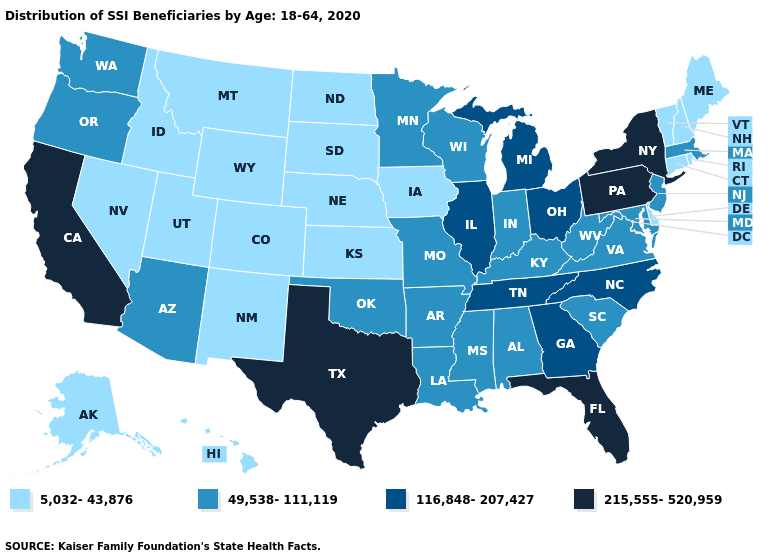Does Kentucky have the highest value in the South?
Give a very brief answer. No. Does the first symbol in the legend represent the smallest category?
Concise answer only. Yes. Which states have the highest value in the USA?
Write a very short answer. California, Florida, New York, Pennsylvania, Texas. Which states have the highest value in the USA?
Be succinct. California, Florida, New York, Pennsylvania, Texas. Name the states that have a value in the range 49,538-111,119?
Answer briefly. Alabama, Arizona, Arkansas, Indiana, Kentucky, Louisiana, Maryland, Massachusetts, Minnesota, Mississippi, Missouri, New Jersey, Oklahoma, Oregon, South Carolina, Virginia, Washington, West Virginia, Wisconsin. What is the lowest value in the USA?
Be succinct. 5,032-43,876. Name the states that have a value in the range 116,848-207,427?
Concise answer only. Georgia, Illinois, Michigan, North Carolina, Ohio, Tennessee. What is the value of Indiana?
Concise answer only. 49,538-111,119. Name the states that have a value in the range 215,555-520,959?
Answer briefly. California, Florida, New York, Pennsylvania, Texas. Name the states that have a value in the range 215,555-520,959?
Concise answer only. California, Florida, New York, Pennsylvania, Texas. Name the states that have a value in the range 215,555-520,959?
Be succinct. California, Florida, New York, Pennsylvania, Texas. What is the lowest value in the USA?
Quick response, please. 5,032-43,876. Does New Mexico have the same value as Nebraska?
Quick response, please. Yes. What is the value of New Jersey?
Write a very short answer. 49,538-111,119. What is the lowest value in states that border Massachusetts?
Quick response, please. 5,032-43,876. 